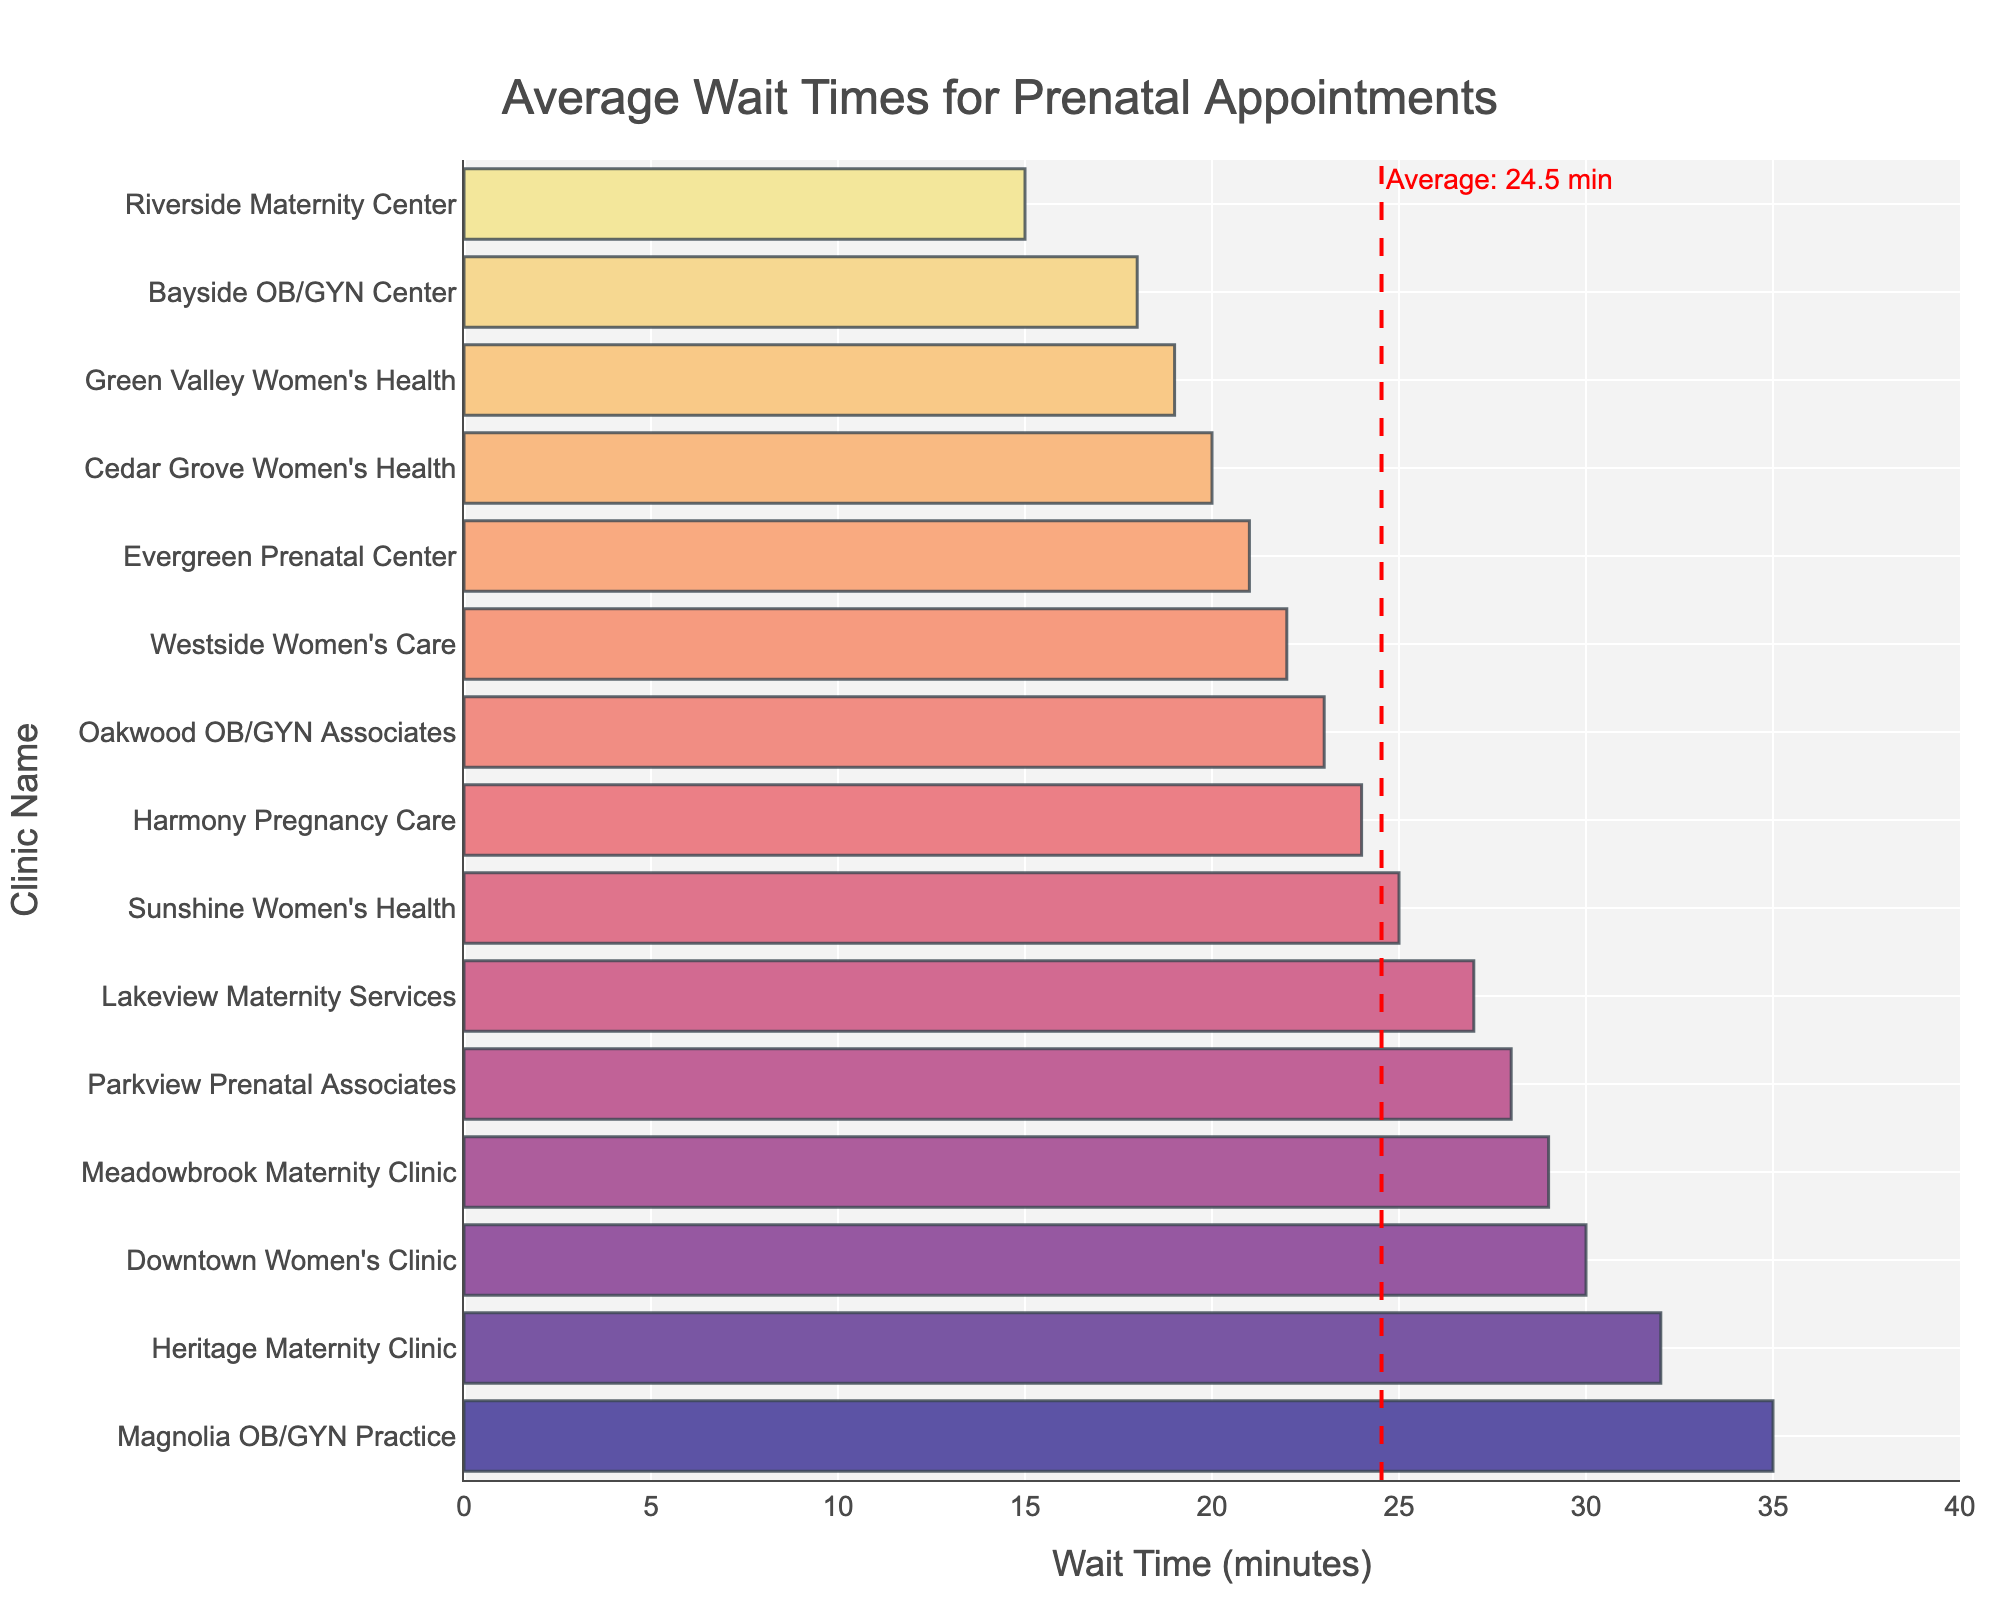What is the clinic with the shortest average wait time? The bar chart's shortest bar corresponds to "Riverside Maternity Center," which indicates it has the shortest wait time.
Answer: Riverside Maternity Center Which clinic has the highest average wait time, and what is that time? The tallest bar in the chart corresponds to "Magnolia OB/GYN Practice," indicating it has the highest wait time of 35 minutes.
Answer: Magnolia OB/GYN Practice, 35 minutes How does the average wait time of "Downtown Women's Clinic" compare with the average line in the chart? The average line in the chart shows the overall average wait time. "Downtown Women's Clinic" has an average wait time of 30 minutes, which is slightly above the average line.
Answer: Slightly above Which clinics have an average wait time lower than the average line? By examining the bars below the red average line, the clinics with lower wait times are "Bayside OB/GYN Center," "Riverside Maternity Center," "Cedar Grove Women's Health," "Green Valley Women's Health," and "Evergreen Prenatal Center."
Answer: Bayside OB/GYN Center, Riverside Maternity Center, Cedar Grove Women's Health, Green Valley Women's Health, Evergreen Prenatal Center What is the average wait time across all clinics? The average wait time is shown as a red dashed line with a label. According to the chart, the average wait time is 24.8 minutes.
Answer: 24.8 minutes How does "Lakeview Maternity Services" compare to "Meadowbrook Maternity Clinic" in terms of average wait time? "Lakeview Maternity Services" has a bar with an average wait time of 27 minutes, while "Meadowbrook Maternity Clinic" has a wait time of 29 minutes, indicating that "Lakeview Maternity Services" has a shorter wait time by 2 minutes.
Answer: Lakeview Maternity Services has a shorter wait time by 2 minutes How many clinics have an average wait time greater than 30 minutes? Counting the bars that exceed the 30-minute mark shows that there are three clinics: "Heritage Maternity Clinic," "Magnolia OB/GYN Practice," and "Downtown Women's Clinic."
Answer: Three clinics Which clinic has a wait time closest to the overall average wait time? The bar closest to the red average line indicates the "Harmony Pregnancy Care," which has an average wait time of 24 minutes, closest to the average of 24.8 minutes.
Answer: Harmony Pregnancy Care What is the total sum of the average wait times for "Sunshine Women's Health" and "Westside Women's Care"? Adding the average wait times: "Sunshine Women's Health" (25 minutes) + "Westside Women's Care" (22 minutes) equals 47 minutes in total.
Answer: 47 minutes Which clinics have wait times between 20 and 25 minutes? Observing the bars within the 20 to 25-minute range, the clinics are "Sunshine Women's Health," "Cedar Grove Women's Health," "Oakwood OB/GYN Associates," and "Evergreen Prenatal Center."
Answer: Sunshine Women's Health, Cedar Grove Women's Health, Oakwood OB/GYN Associates, Evergreen Prenatal Center 